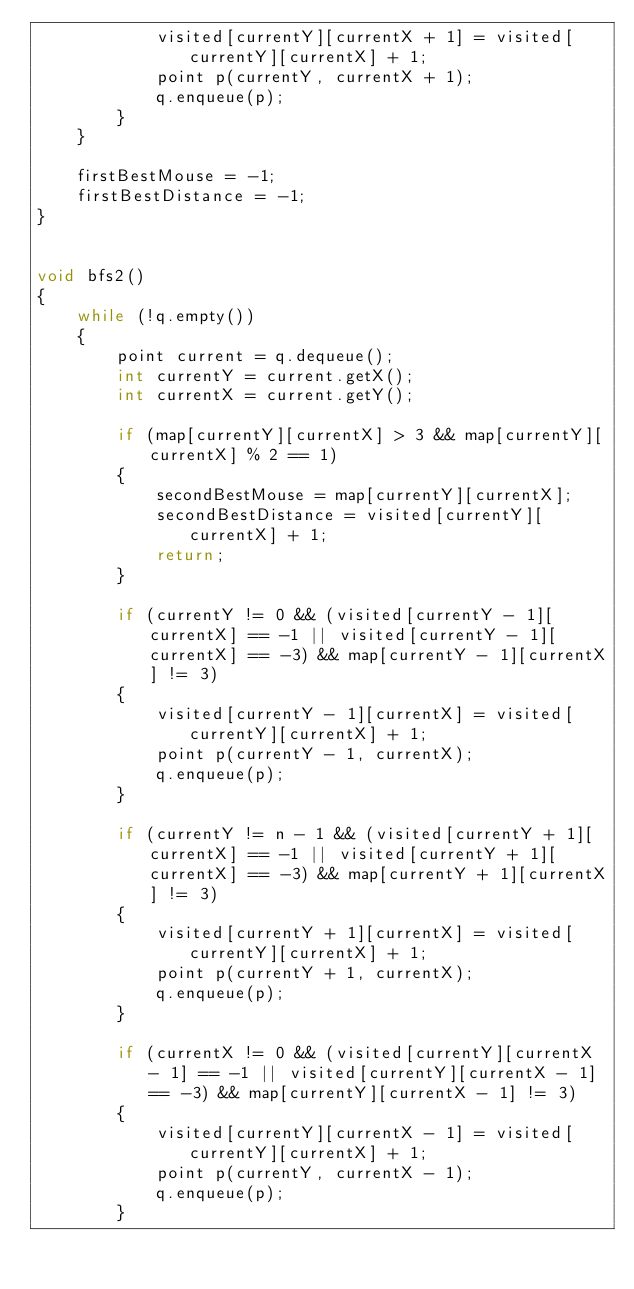<code> <loc_0><loc_0><loc_500><loc_500><_C++_>            visited[currentY][currentX + 1] = visited[currentY][currentX] + 1;
            point p(currentY, currentX + 1);
            q.enqueue(p);
        }
    }

    firstBestMouse = -1;
    firstBestDistance = -1;
}


void bfs2()
{
    while (!q.empty())
    {
        point current = q.dequeue();
        int currentY = current.getX();
        int currentX = current.getY();

        if (map[currentY][currentX] > 3 && map[currentY][currentX] % 2 == 1)
        {
            secondBestMouse = map[currentY][currentX];
            secondBestDistance = visited[currentY][currentX] + 1;
            return;
        }

        if (currentY != 0 && (visited[currentY - 1][currentX] == -1 || visited[currentY - 1][currentX] == -3) && map[currentY - 1][currentX] != 3)
        {
            visited[currentY - 1][currentX] = visited[currentY][currentX] + 1;
            point p(currentY - 1, currentX);
            q.enqueue(p);
        }

        if (currentY != n - 1 && (visited[currentY + 1][currentX] == -1 || visited[currentY + 1][currentX] == -3) && map[currentY + 1][currentX] != 3)
        {
            visited[currentY + 1][currentX] = visited[currentY][currentX] + 1;
            point p(currentY + 1, currentX);
            q.enqueue(p);
        }

        if (currentX != 0 && (visited[currentY][currentX - 1] == -1 || visited[currentY][currentX - 1] == -3) && map[currentY][currentX - 1] != 3)
        {
            visited[currentY][currentX - 1] = visited[currentY][currentX] + 1;
            point p(currentY, currentX - 1);
            q.enqueue(p);
        }
</code> 